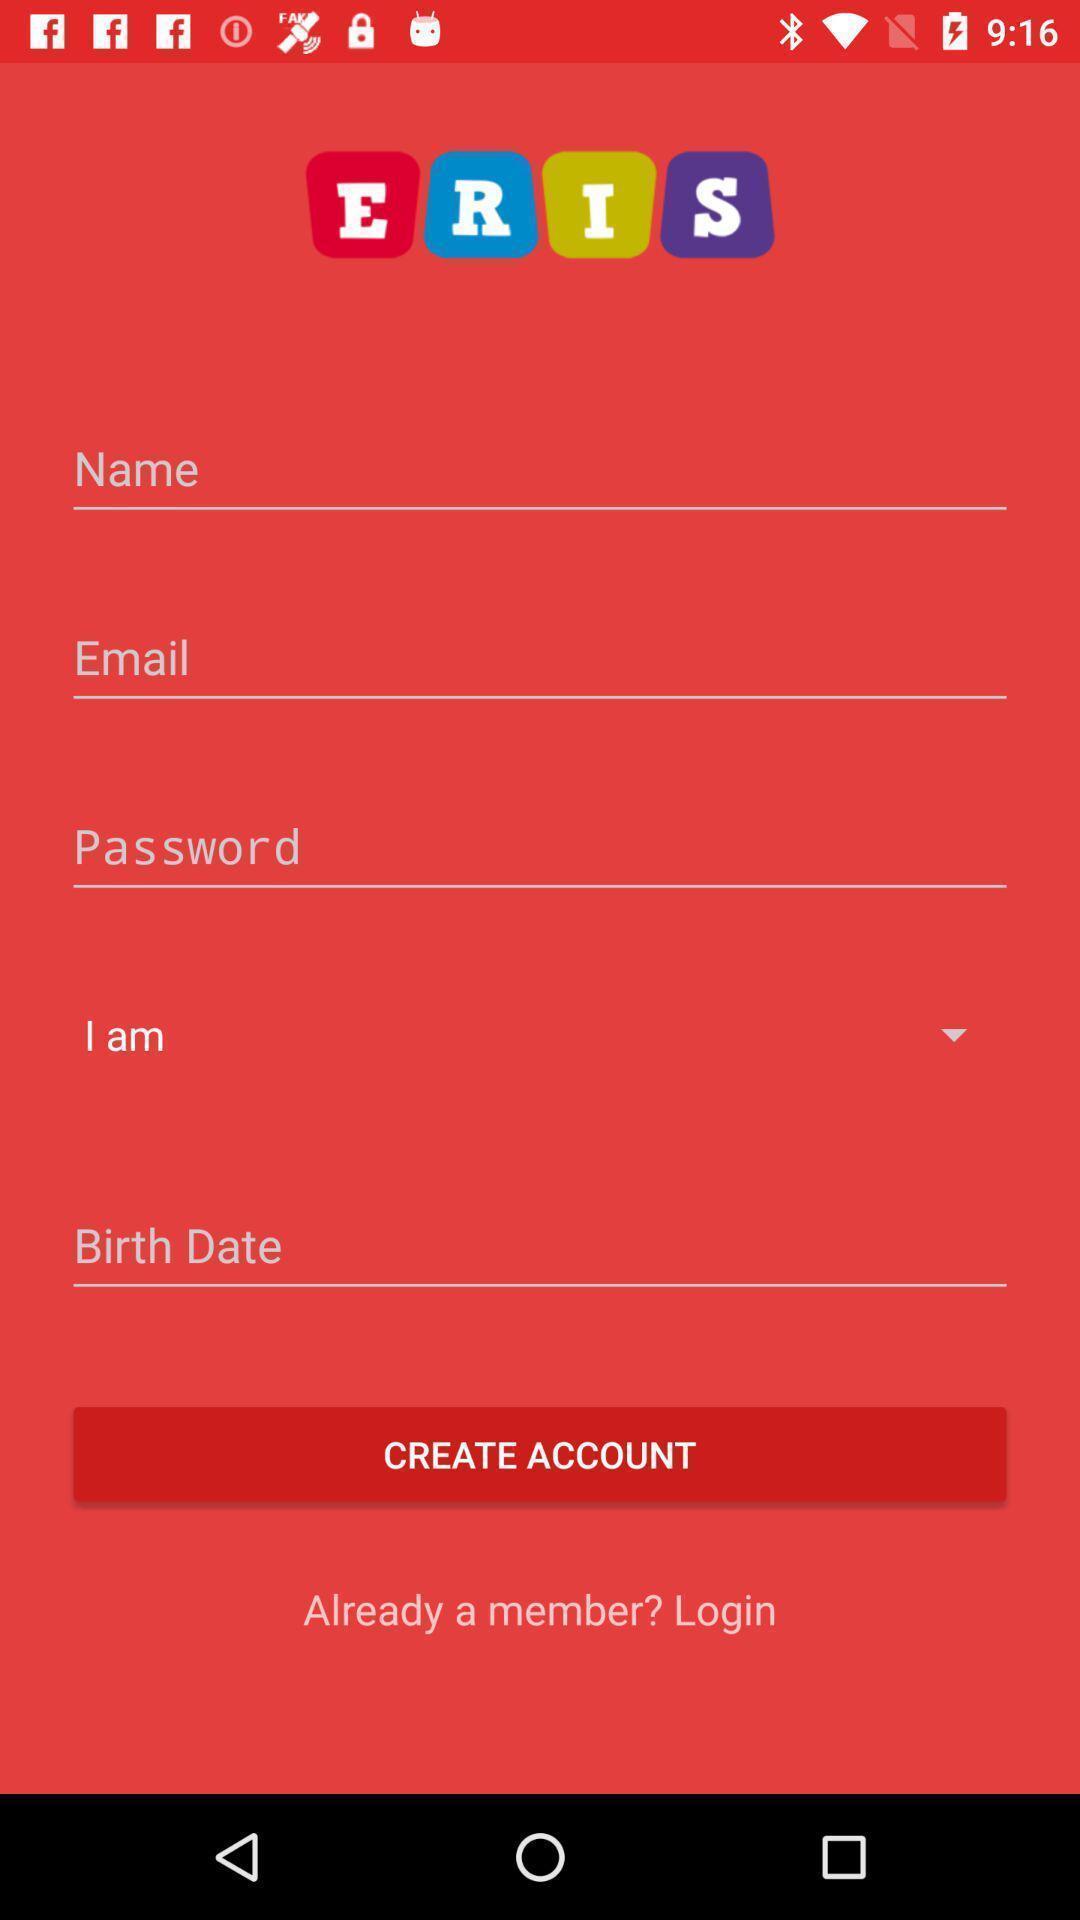What details can you identify in this image? Welcome page with different options. 